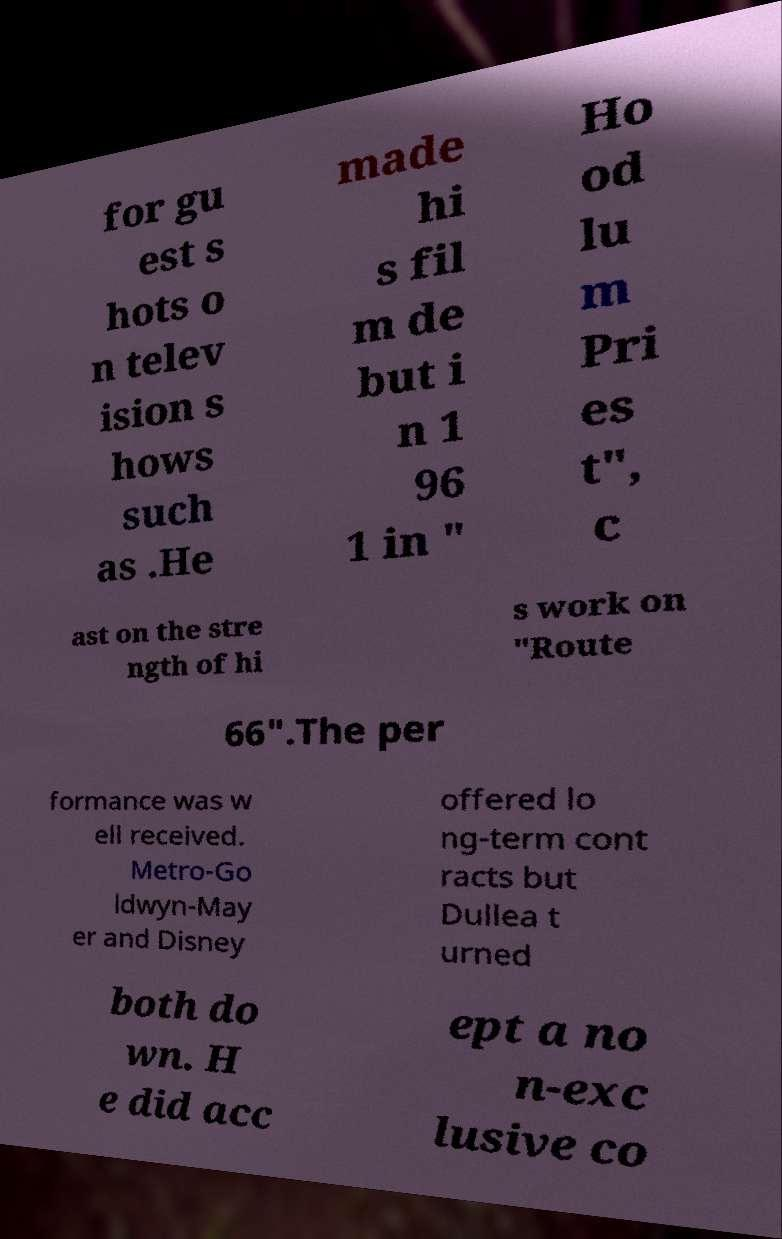Can you read and provide the text displayed in the image?This photo seems to have some interesting text. Can you extract and type it out for me? for gu est s hots o n telev ision s hows such as .He made hi s fil m de but i n 1 96 1 in " Ho od lu m Pri es t", c ast on the stre ngth of hi s work on "Route 66".The per formance was w ell received. Metro-Go ldwyn-May er and Disney offered lo ng-term cont racts but Dullea t urned both do wn. H e did acc ept a no n-exc lusive co 